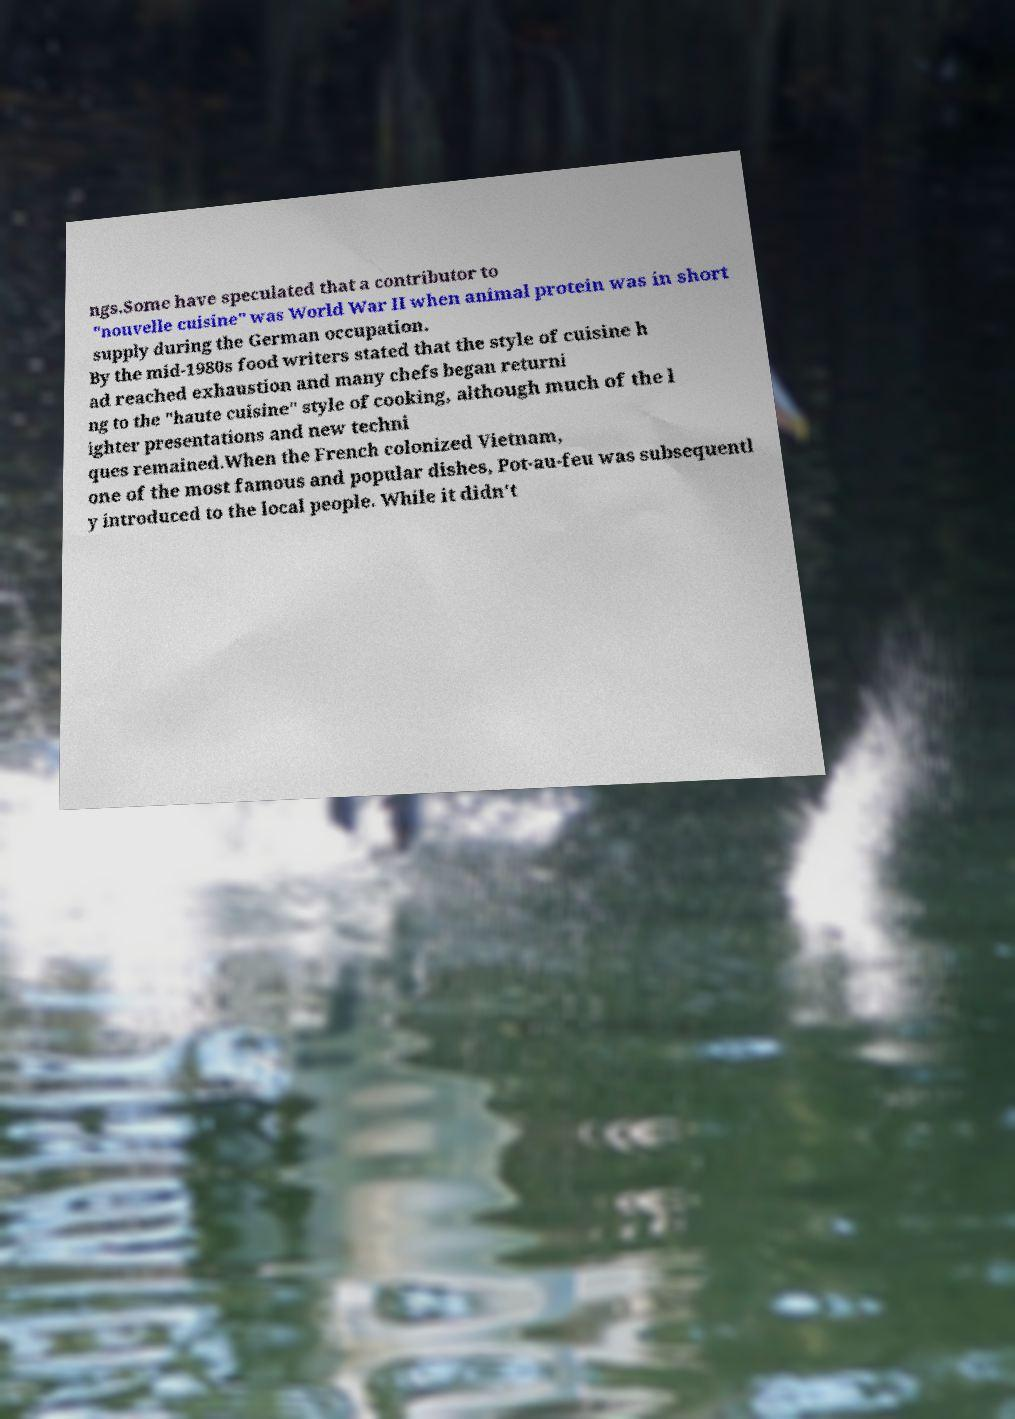Can you read and provide the text displayed in the image?This photo seems to have some interesting text. Can you extract and type it out for me? ngs.Some have speculated that a contributor to "nouvelle cuisine" was World War II when animal protein was in short supply during the German occupation. By the mid-1980s food writers stated that the style of cuisine h ad reached exhaustion and many chefs began returni ng to the "haute cuisine" style of cooking, although much of the l ighter presentations and new techni ques remained.When the French colonized Vietnam, one of the most famous and popular dishes, Pot-au-feu was subsequentl y introduced to the local people. While it didn't 